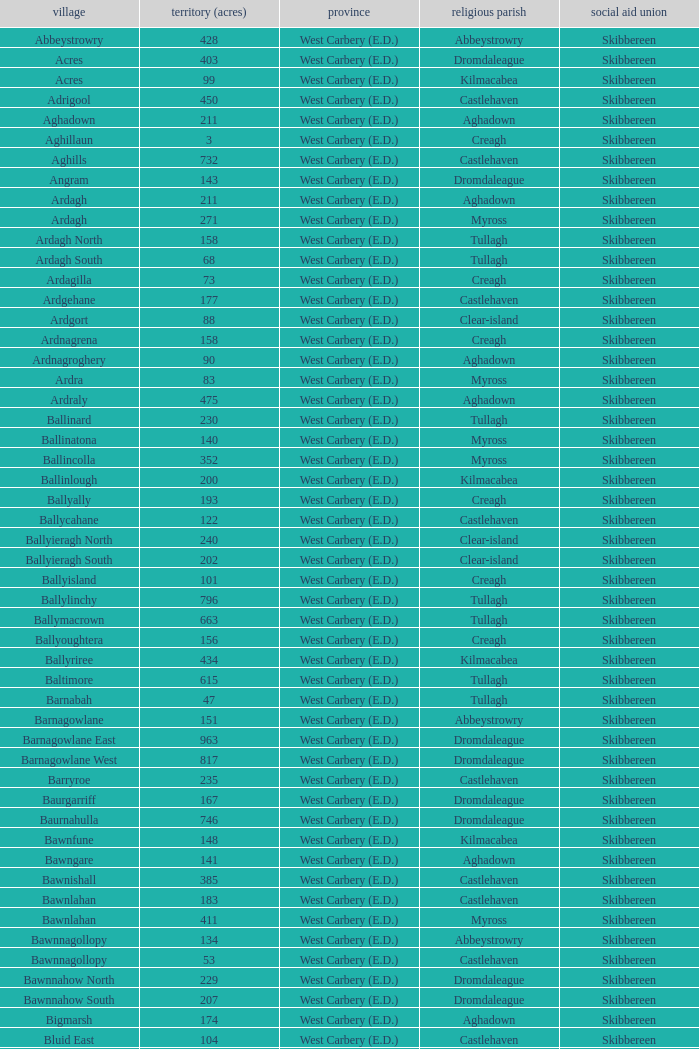What are the Poor Law Unions when the area (in acres) is 142? Skibbereen. 